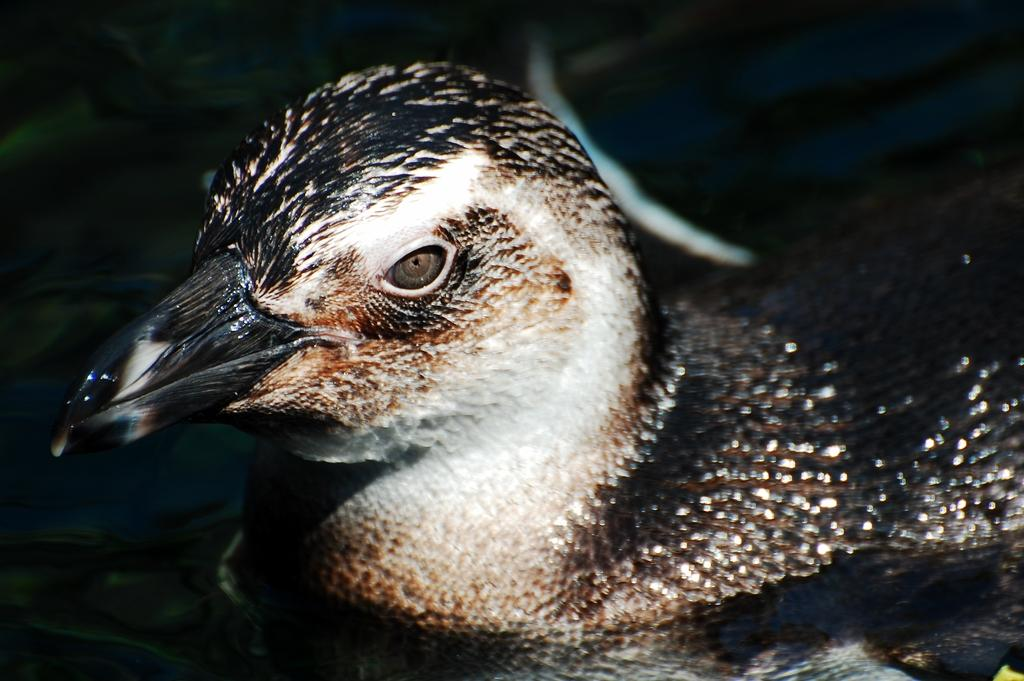What is the main subject of the image? There is a bird in the center of the image. Can you describe the bird in the image? The bird is the main focus of the image, but no specific details about its appearance are provided. What is the bird's position in the image? The bird is in the center of the image. What type of needle is the bird using to sew a sheet in the image? There is no needle or sheet present in the image; it only features a bird in the center. 